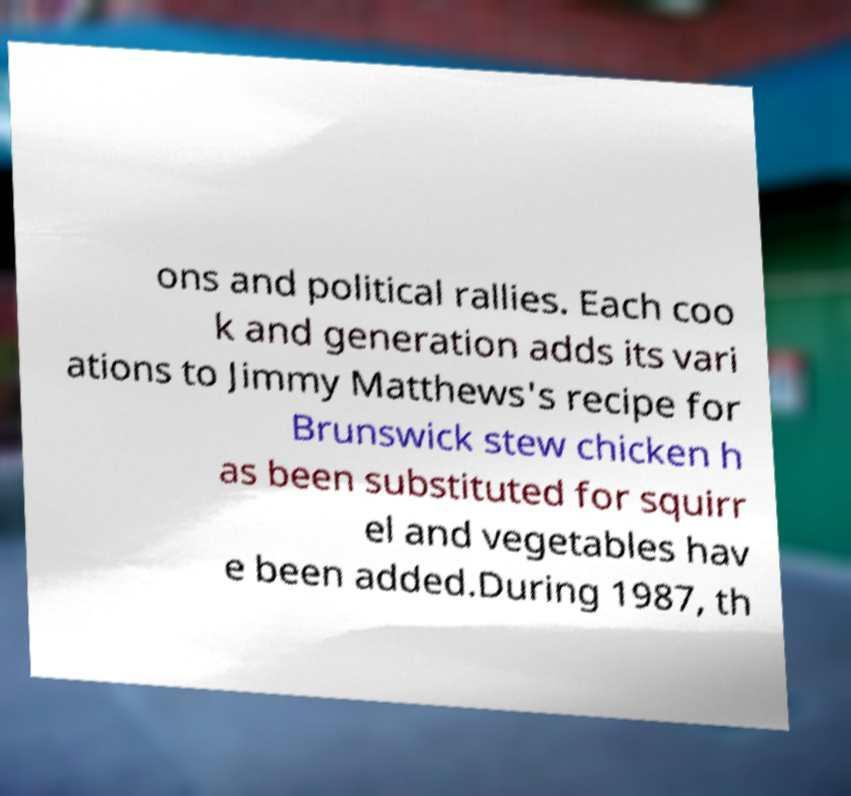What messages or text are displayed in this image? I need them in a readable, typed format. ons and political rallies. Each coo k and generation adds its vari ations to Jimmy Matthews's recipe for Brunswick stew chicken h as been substituted for squirr el and vegetables hav e been added.During 1987, th 